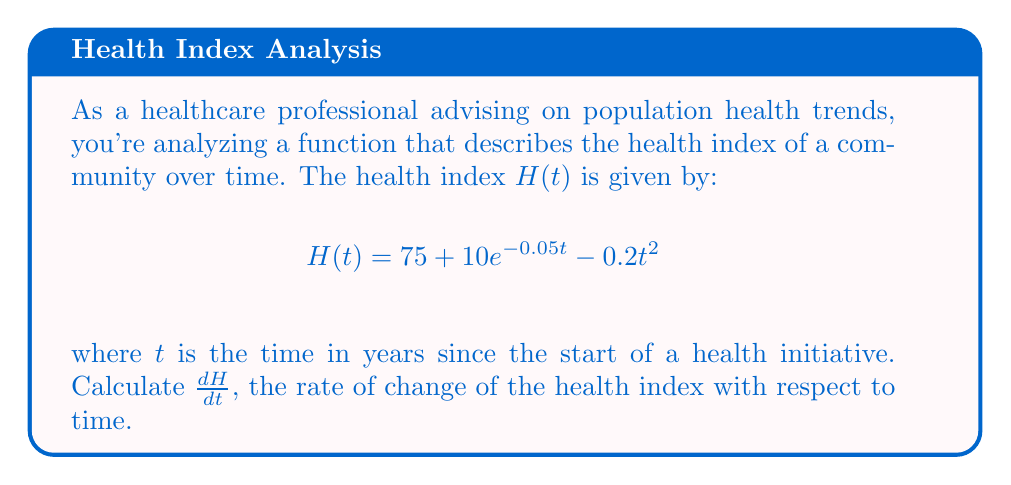Can you answer this question? To find the derivative of $H(t)$ with respect to $t$, we need to apply the sum and difference rules of differentiation, along with the chain rule for the exponential term.

1) First, let's break down the function into its components:
   $$H(t) = 75 + 10e^{-0.05t} - 0.2t^2$$

2) Now, let's differentiate each term:
   
   a) The constant term: $\frac{d}{dt}(75) = 0$
   
   b) The exponential term: $\frac{d}{dt}(10e^{-0.05t})$
      Using the chain rule: $10 \cdot (-0.05) \cdot e^{-0.05t} = -0.5e^{-0.05t}$
   
   c) The quadratic term: $\frac{d}{dt}(-0.2t^2)$
      Using the power rule: $-0.2 \cdot 2t = -0.4t$

3) Combining these results:

   $$\frac{dH}{dt} = 0 + (-0.5e^{-0.05t}) + (-0.4t)$$

4) Simplifying:

   $$\frac{dH}{dt} = -0.5e^{-0.05t} - 0.4t$$

This derivative represents the instantaneous rate of change of the health index at any given time $t$.
Answer: $\frac{dH}{dt} = -0.5e^{-0.05t} - 0.4t$ 